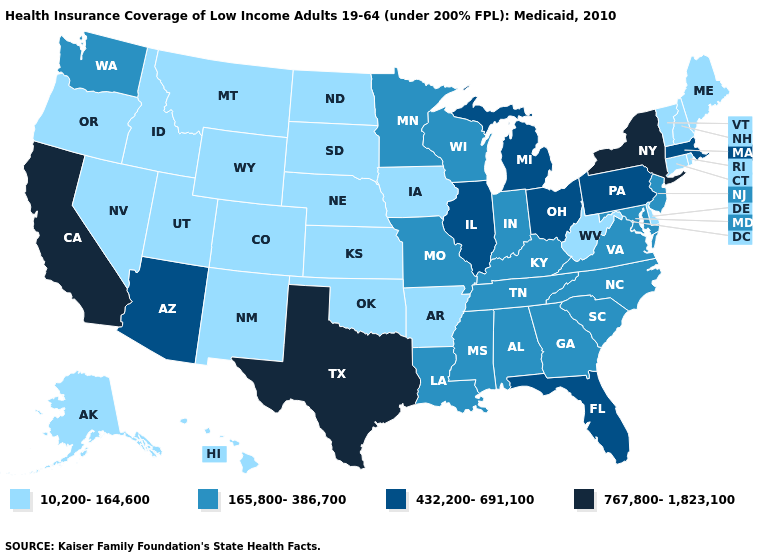What is the lowest value in the USA?
Give a very brief answer. 10,200-164,600. Is the legend a continuous bar?
Answer briefly. No. Among the states that border Kansas , which have the highest value?
Be succinct. Missouri. How many symbols are there in the legend?
Quick response, please. 4. What is the highest value in the USA?
Give a very brief answer. 767,800-1,823,100. Among the states that border Arizona , does California have the lowest value?
Be succinct. No. Name the states that have a value in the range 10,200-164,600?
Short answer required. Alaska, Arkansas, Colorado, Connecticut, Delaware, Hawaii, Idaho, Iowa, Kansas, Maine, Montana, Nebraska, Nevada, New Hampshire, New Mexico, North Dakota, Oklahoma, Oregon, Rhode Island, South Dakota, Utah, Vermont, West Virginia, Wyoming. Name the states that have a value in the range 165,800-386,700?
Write a very short answer. Alabama, Georgia, Indiana, Kentucky, Louisiana, Maryland, Minnesota, Mississippi, Missouri, New Jersey, North Carolina, South Carolina, Tennessee, Virginia, Washington, Wisconsin. What is the lowest value in the South?
Short answer required. 10,200-164,600. Name the states that have a value in the range 10,200-164,600?
Answer briefly. Alaska, Arkansas, Colorado, Connecticut, Delaware, Hawaii, Idaho, Iowa, Kansas, Maine, Montana, Nebraska, Nevada, New Hampshire, New Mexico, North Dakota, Oklahoma, Oregon, Rhode Island, South Dakota, Utah, Vermont, West Virginia, Wyoming. Does New Mexico have a lower value than Texas?
Quick response, please. Yes. What is the value of Ohio?
Short answer required. 432,200-691,100. Name the states that have a value in the range 432,200-691,100?
Write a very short answer. Arizona, Florida, Illinois, Massachusetts, Michigan, Ohio, Pennsylvania. Name the states that have a value in the range 165,800-386,700?
Short answer required. Alabama, Georgia, Indiana, Kentucky, Louisiana, Maryland, Minnesota, Mississippi, Missouri, New Jersey, North Carolina, South Carolina, Tennessee, Virginia, Washington, Wisconsin. 